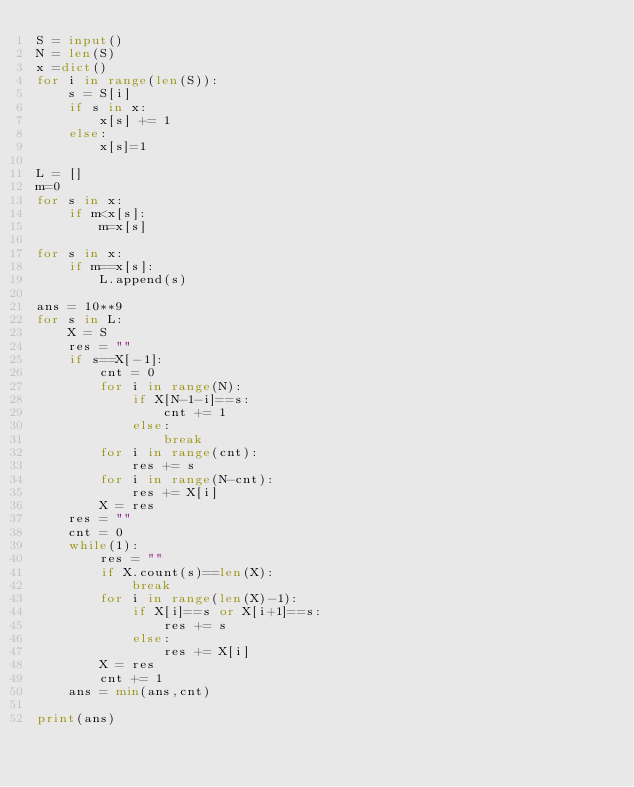Convert code to text. <code><loc_0><loc_0><loc_500><loc_500><_Python_>S = input()
N = len(S)
x =dict()
for i in range(len(S)):
    s = S[i]
    if s in x:
        x[s] += 1
    else:
        x[s]=1

L = []
m=0
for s in x:
    if m<x[s]:
        m=x[s]

for s in x:
    if m==x[s]:
        L.append(s)

ans = 10**9
for s in L:
    X = S
    res = ""
    if s==X[-1]:
        cnt = 0
        for i in range(N):
            if X[N-1-i]==s:
                cnt += 1
            else:
                break
        for i in range(cnt):
            res += s
        for i in range(N-cnt):
            res += X[i]
        X = res 
    res = ""
    cnt = 0
    while(1):
        res = ""
        if X.count(s)==len(X):
            break
        for i in range(len(X)-1):
            if X[i]==s or X[i+1]==s:
                res += s
            else:
                res += X[i]
        X = res
        cnt += 1
    ans = min(ans,cnt)

print(ans)
</code> 